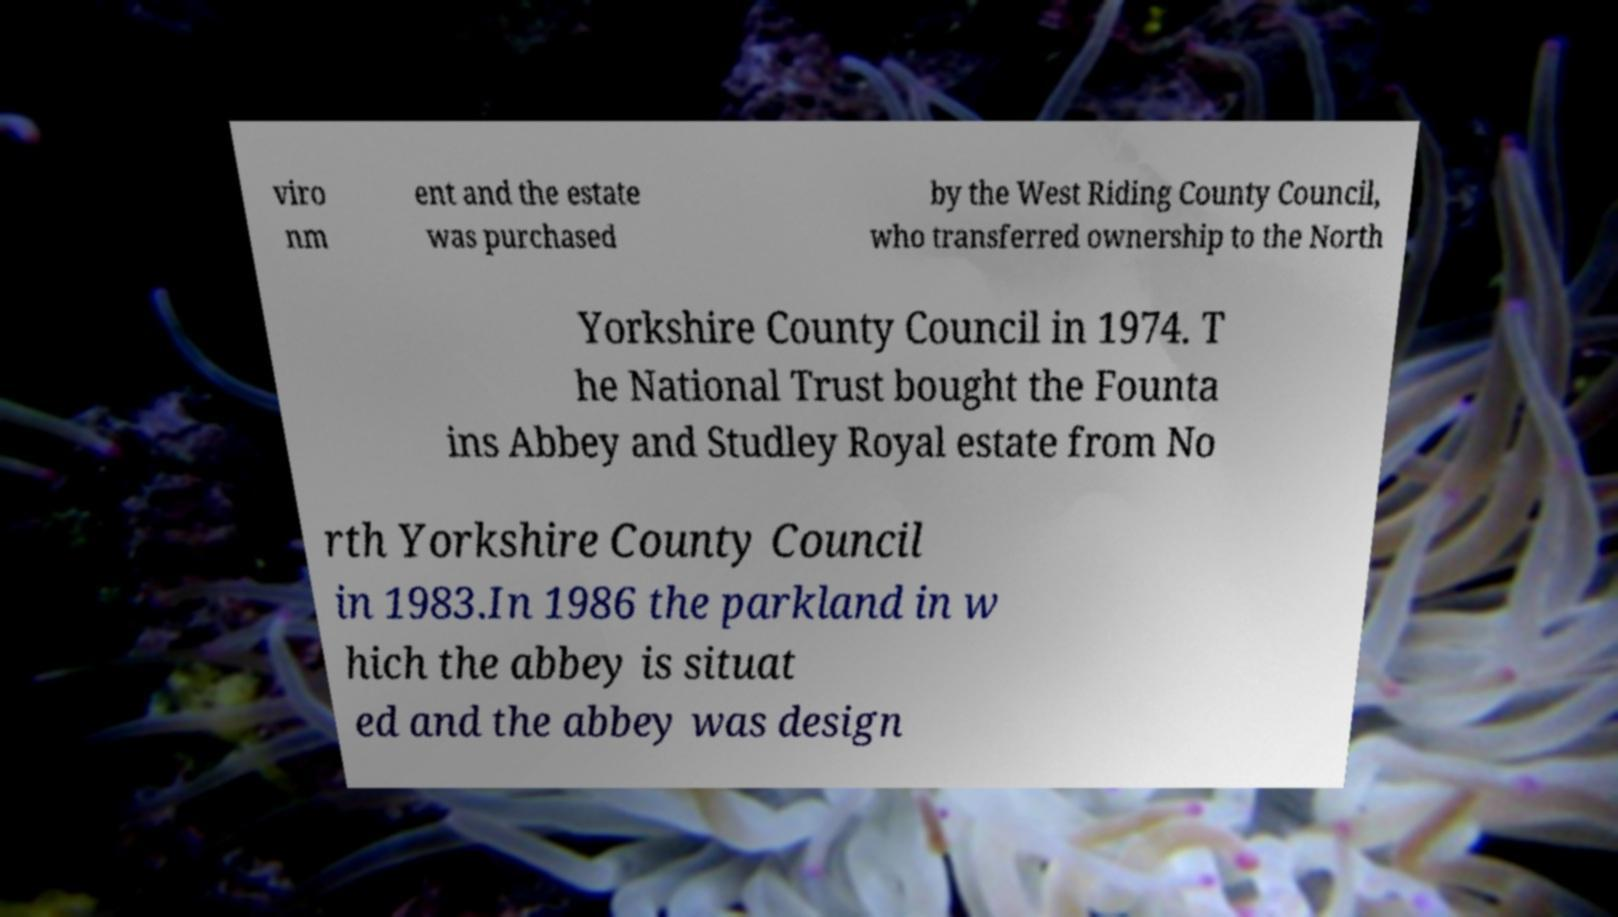Please identify and transcribe the text found in this image. viro nm ent and the estate was purchased by the West Riding County Council, who transferred ownership to the North Yorkshire County Council in 1974. T he National Trust bought the Founta ins Abbey and Studley Royal estate from No rth Yorkshire County Council in 1983.In 1986 the parkland in w hich the abbey is situat ed and the abbey was design 